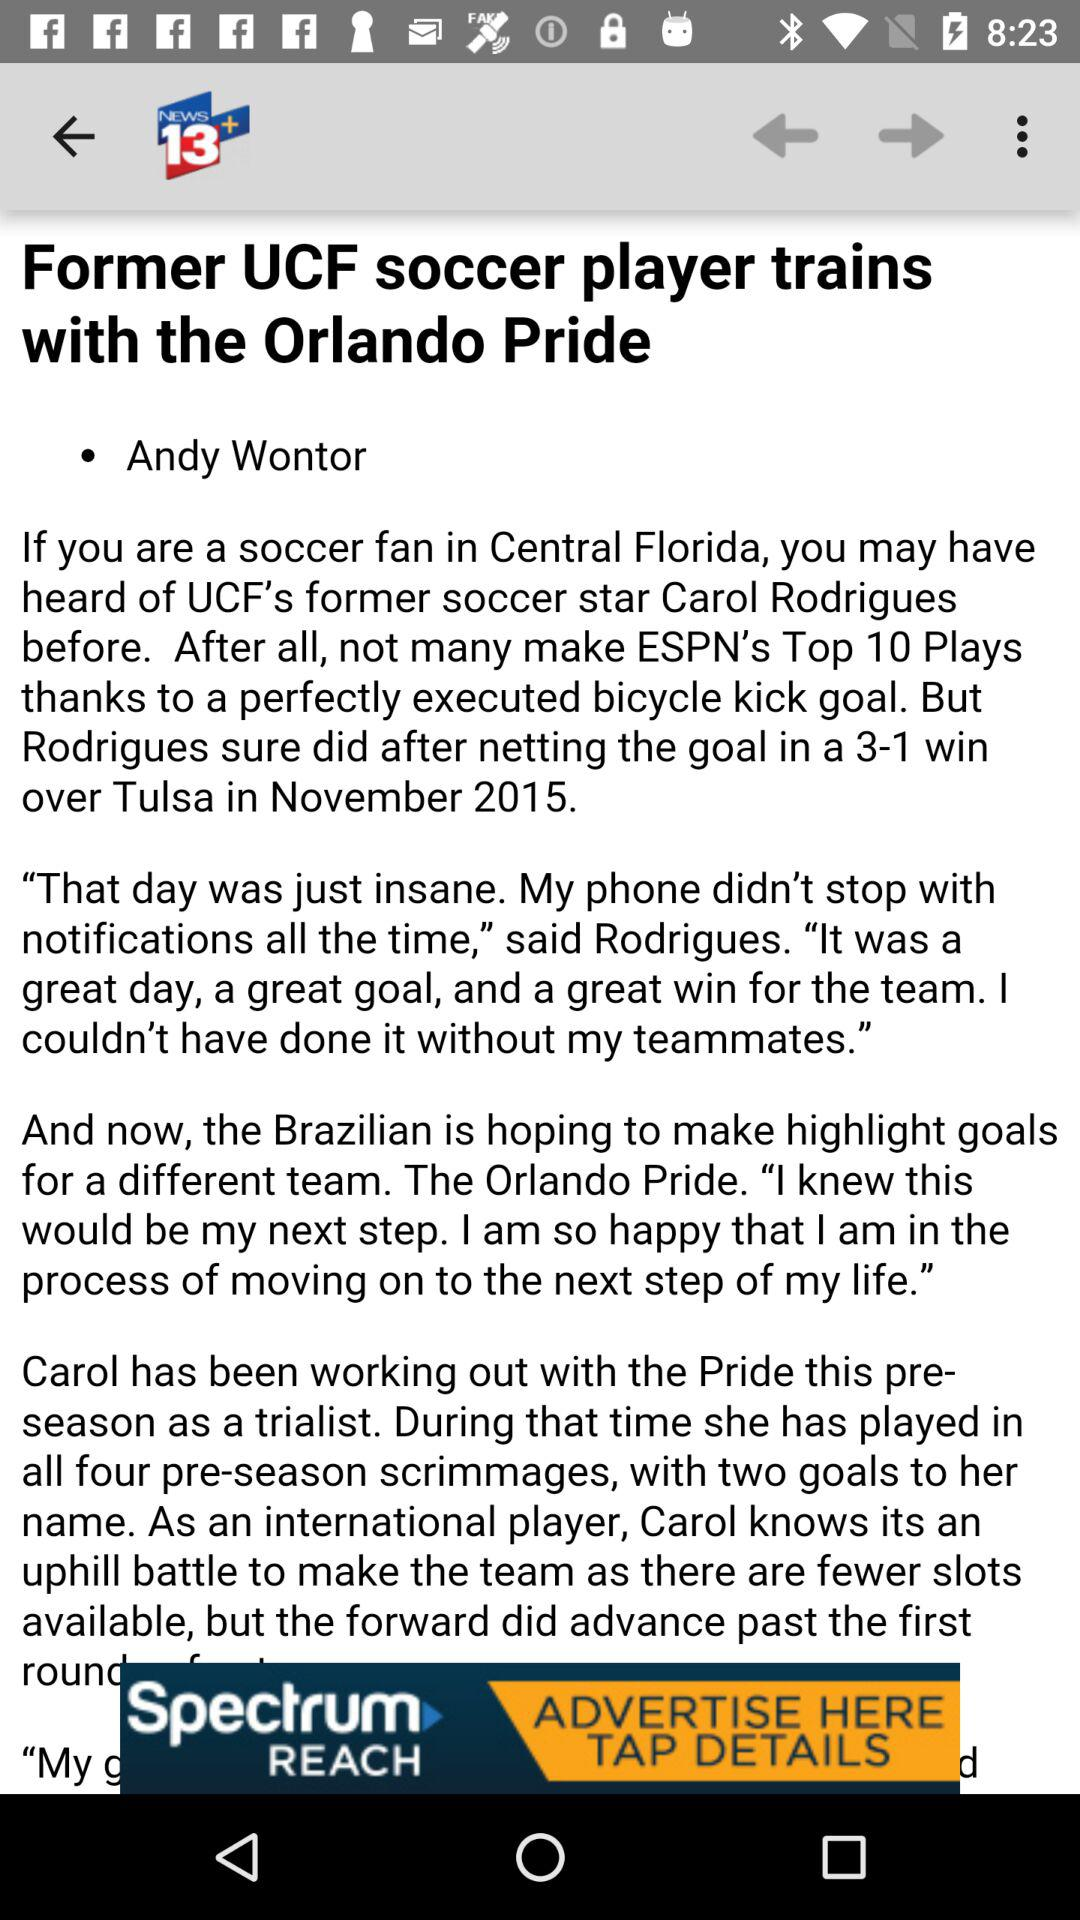What's the article headline? The article headline is "Former UCF soccer player trains with the Orlando Pride". 